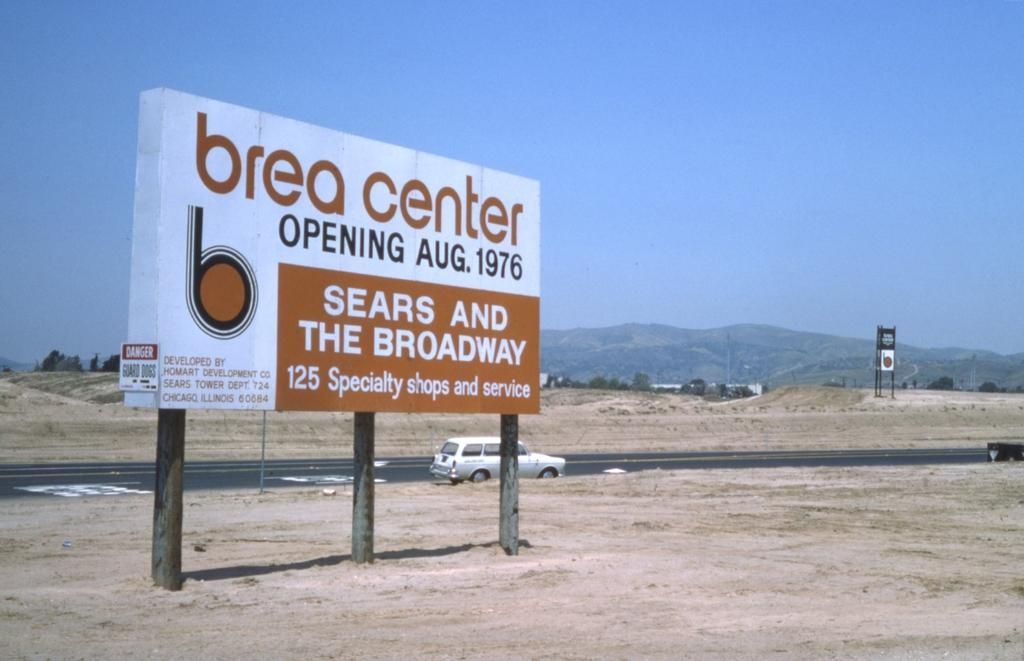<image>
Create a compact narrative representing the image presented. a sign that says brea center on it 